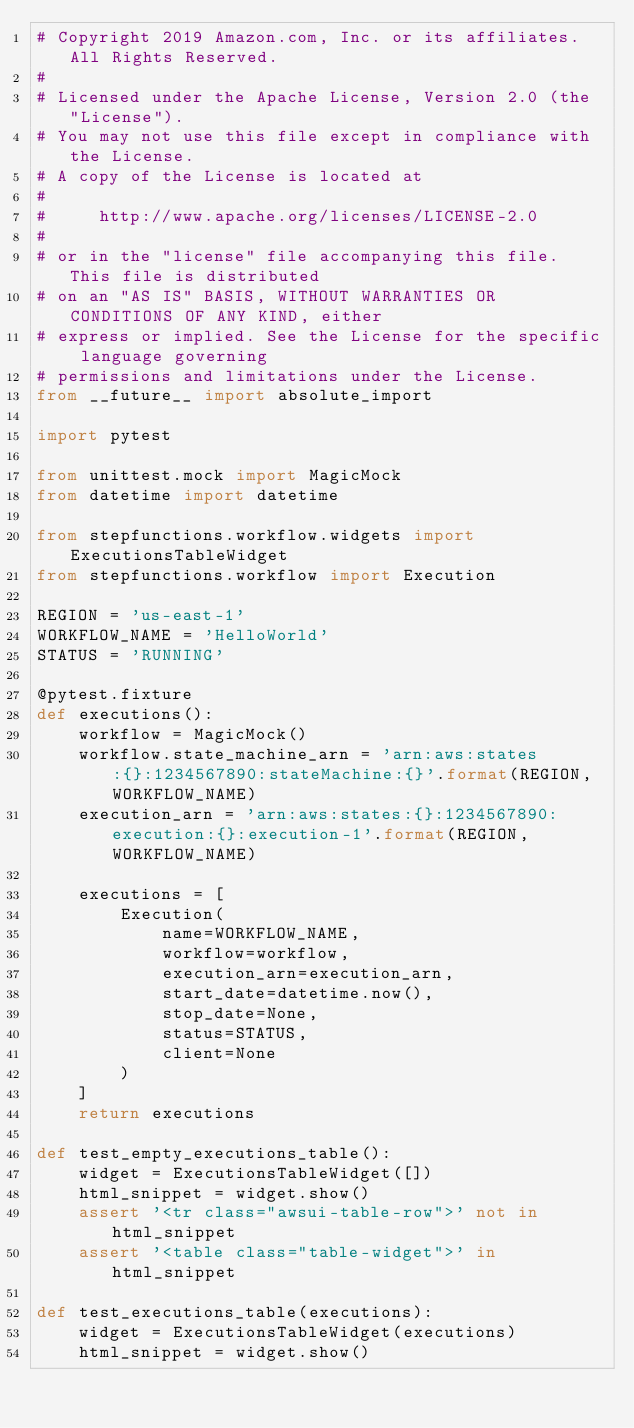<code> <loc_0><loc_0><loc_500><loc_500><_Python_># Copyright 2019 Amazon.com, Inc. or its affiliates. All Rights Reserved.
#
# Licensed under the Apache License, Version 2.0 (the "License").
# You may not use this file except in compliance with the License.
# A copy of the License is located at
#
#     http://www.apache.org/licenses/LICENSE-2.0
#
# or in the "license" file accompanying this file. This file is distributed 
# on an "AS IS" BASIS, WITHOUT WARRANTIES OR CONDITIONS OF ANY KIND, either 
# express or implied. See the License for the specific language governing 
# permissions and limitations under the License.
from __future__ import absolute_import

import pytest

from unittest.mock import MagicMock
from datetime import datetime

from stepfunctions.workflow.widgets import ExecutionsTableWidget
from stepfunctions.workflow import Execution

REGION = 'us-east-1'
WORKFLOW_NAME = 'HelloWorld'
STATUS = 'RUNNING'

@pytest.fixture
def executions():
    workflow = MagicMock()
    workflow.state_machine_arn = 'arn:aws:states:{}:1234567890:stateMachine:{}'.format(REGION, WORKFLOW_NAME)
    execution_arn = 'arn:aws:states:{}:1234567890:execution:{}:execution-1'.format(REGION, WORKFLOW_NAME)

    executions = [
        Execution(
            name=WORKFLOW_NAME,
            workflow=workflow,
            execution_arn=execution_arn,
            start_date=datetime.now(),
            stop_date=None,
            status=STATUS,
            client=None
        )
    ]
    return executions

def test_empty_executions_table():
    widget = ExecutionsTableWidget([])
    html_snippet = widget.show()
    assert '<tr class="awsui-table-row">' not in html_snippet
    assert '<table class="table-widget">' in html_snippet

def test_executions_table(executions):
    widget = ExecutionsTableWidget(executions)
    html_snippet = widget.show()</code> 